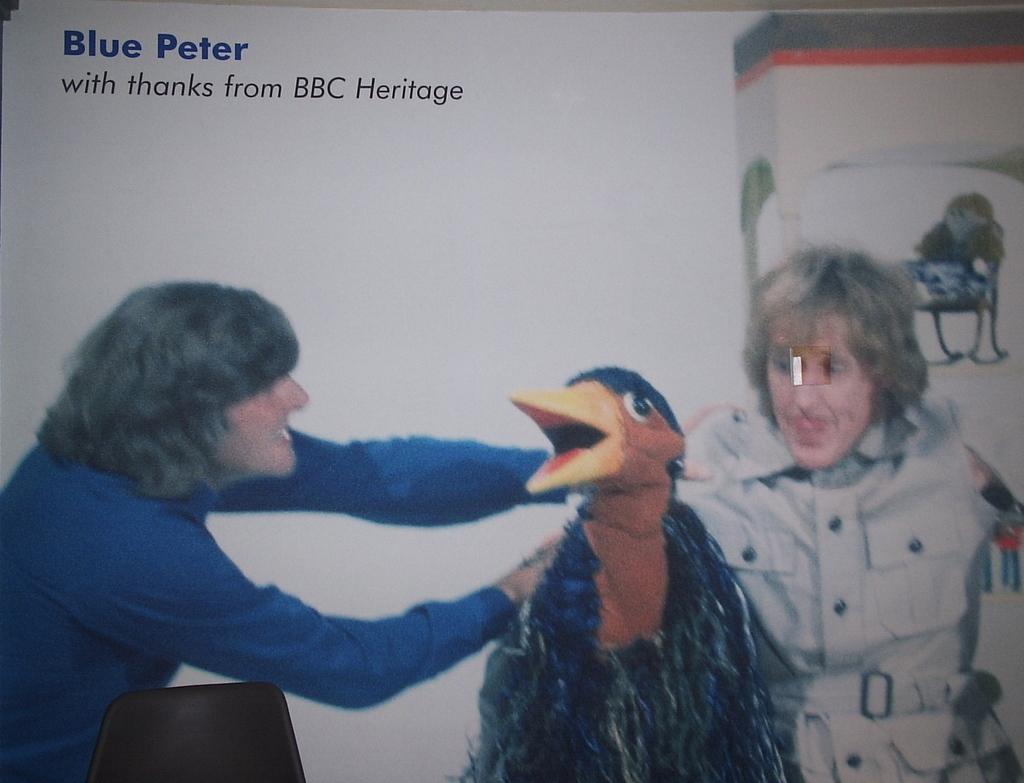Describe this image in one or two sentences. In this picture I can see the poster. I can see two persons in the poster. 